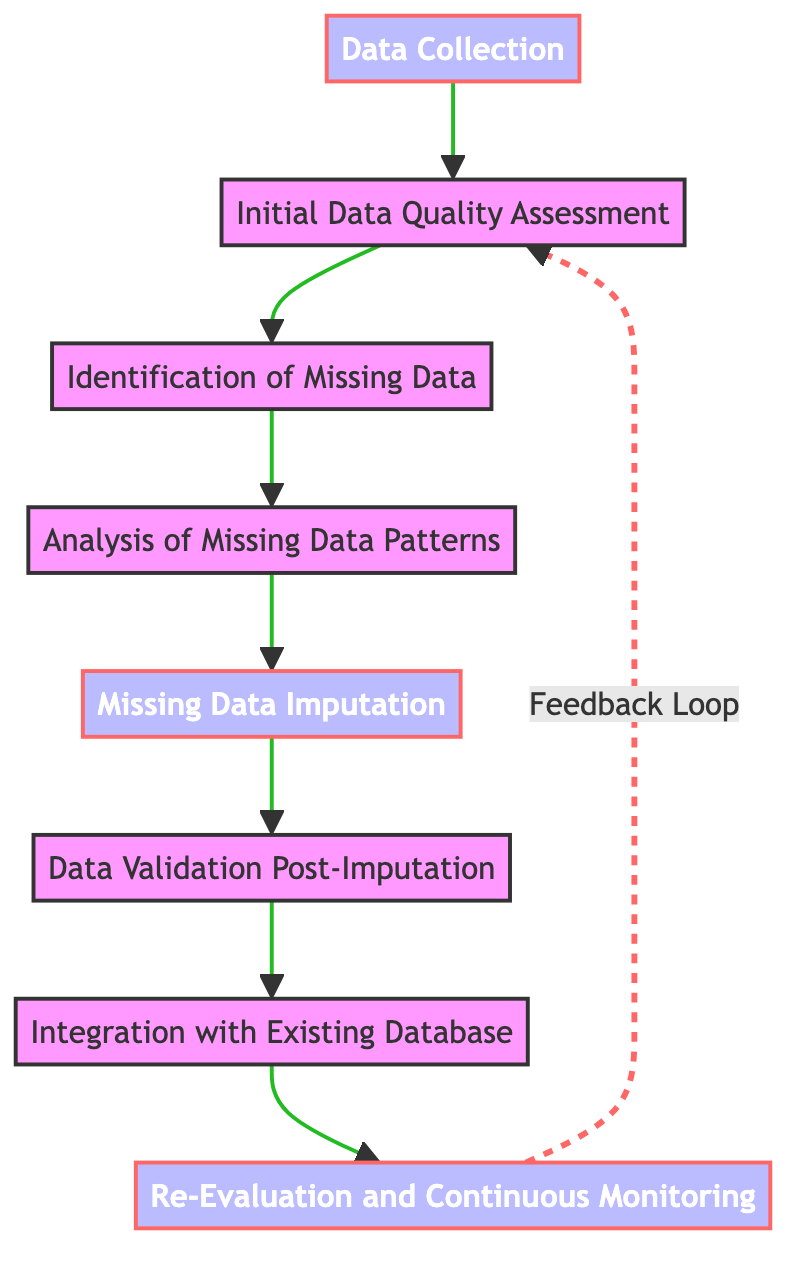What is the starting point of the process? The flowchart begins with the node labeled "Data Collection," indicating that this is the first step in the process of handling missing data in large-scale astronomical surveys.
Answer: Data Collection How many nodes are present in the flowchart? By counting the distinct steps outlined in the flowchart, we see there are a total of eight nodes.
Answer: 8 Which node follows "Identification of Missing Data"? After "Identification of Missing Data," the next step in the process is "Analysis of Missing Data Patterns," as indicated by the arrow connecting these two nodes.
Answer: Analysis of Missing Data Patterns What type of feedback mechanism is shown in the flowchart? The flowchart illustrates a feedback loop from "Re-Evaluation and Continuous Monitoring" back to "Initial Data Quality Assessment," signifying ongoing assessment and potential re-assessment of data quality.
Answer: Feedback Loop Which imputation strategy is mentioned in the flowchart? The flowchart mentions several imputation strategies under the node "Missing Data Imputation," with examples like Mean/Median Imputation.
Answer: Mean/Median Imputation What tools are suggested for integrating validated data into the database? The flowchart specifies the use of Database Management Systems such as MySQL and PostgreSQL for the integration of validated data into the existing database.
Answer: MySQL, PostgreSQL How does the process ensure the accuracy of imputed data? The flowchart indicates that "Data Validation Post-Imputation" is performed to ensure the imputed data reflects actual astronomical observations, employing methods like Cross-Validation and Comparison with Simulated Data Sets.
Answer: Data Validation Post-Imputation What is the primary goal of "Analysis of Missing Data Patterns"? The primary goal of this step is to determine the nature of the missing data, classifying it as Missing Completely at Random, Missing at Random, or Missing Not at Random, which is essential for choosing the right imputation method.
Answer: Determine missing data nature 